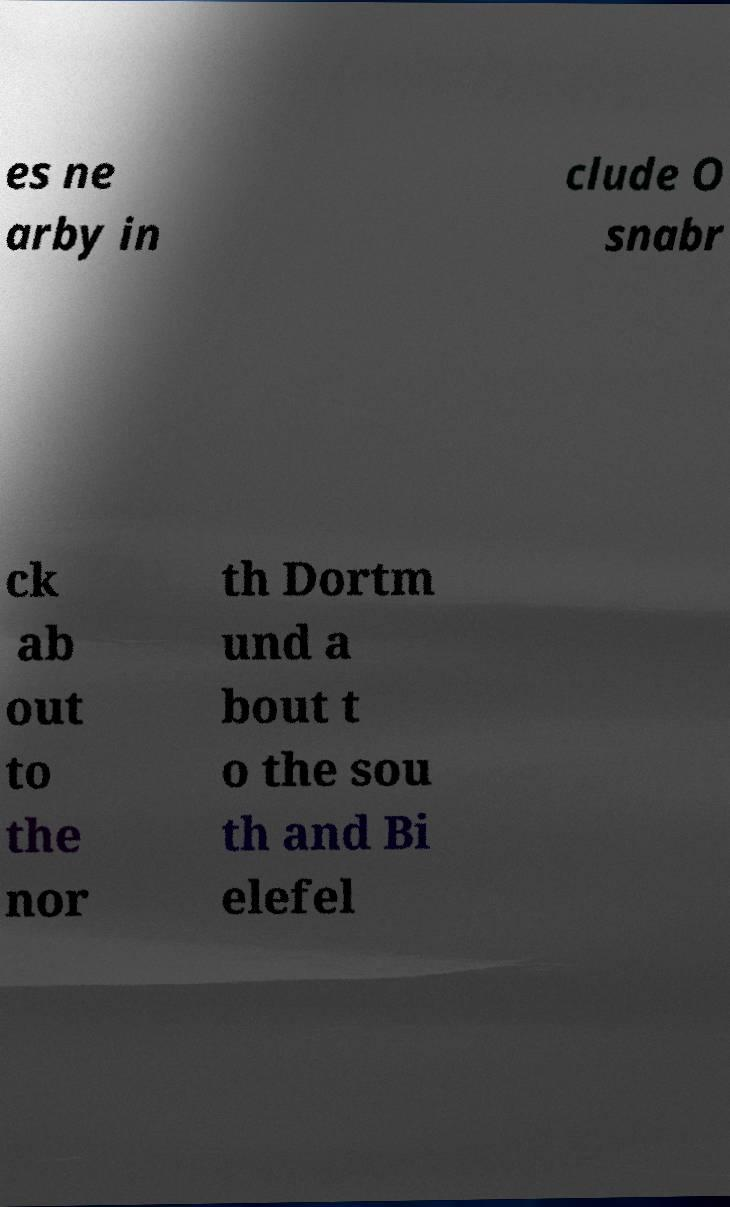Could you assist in decoding the text presented in this image and type it out clearly? es ne arby in clude O snabr ck ab out to the nor th Dortm und a bout t o the sou th and Bi elefel 